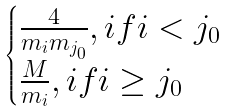<formula> <loc_0><loc_0><loc_500><loc_500>\begin{cases} \frac { 4 } { m _ { i } m _ { j _ { 0 } } } , i f i < j _ { 0 } \\ \frac { M } { m _ { i } } , i f i \geq j _ { 0 } \end{cases}</formula> 